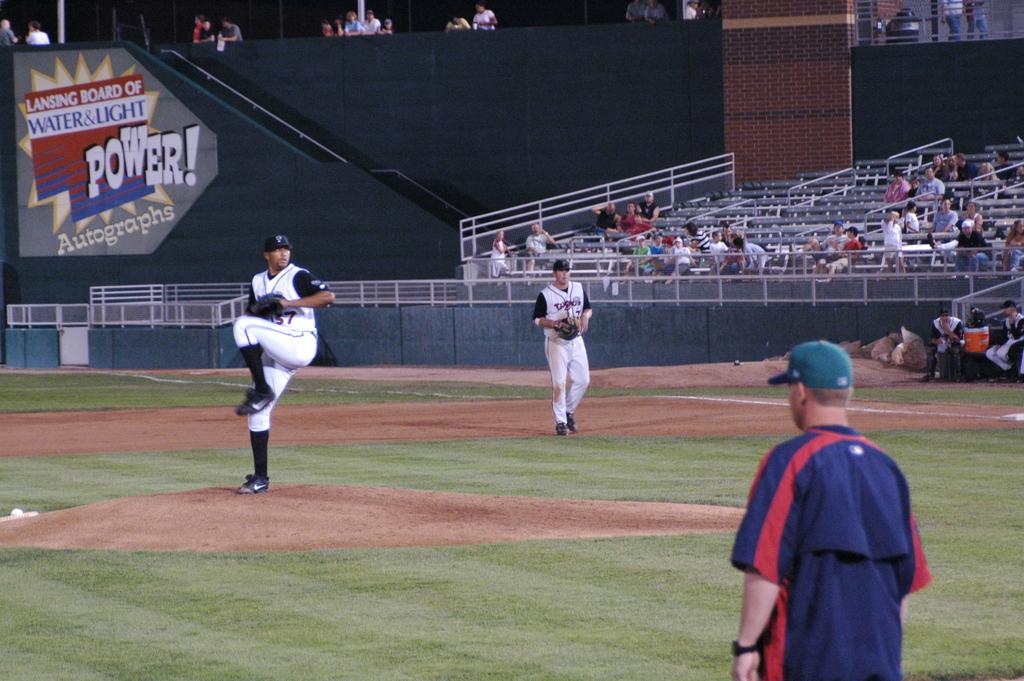What is the number of the pitcher?
Give a very brief answer. 37. 